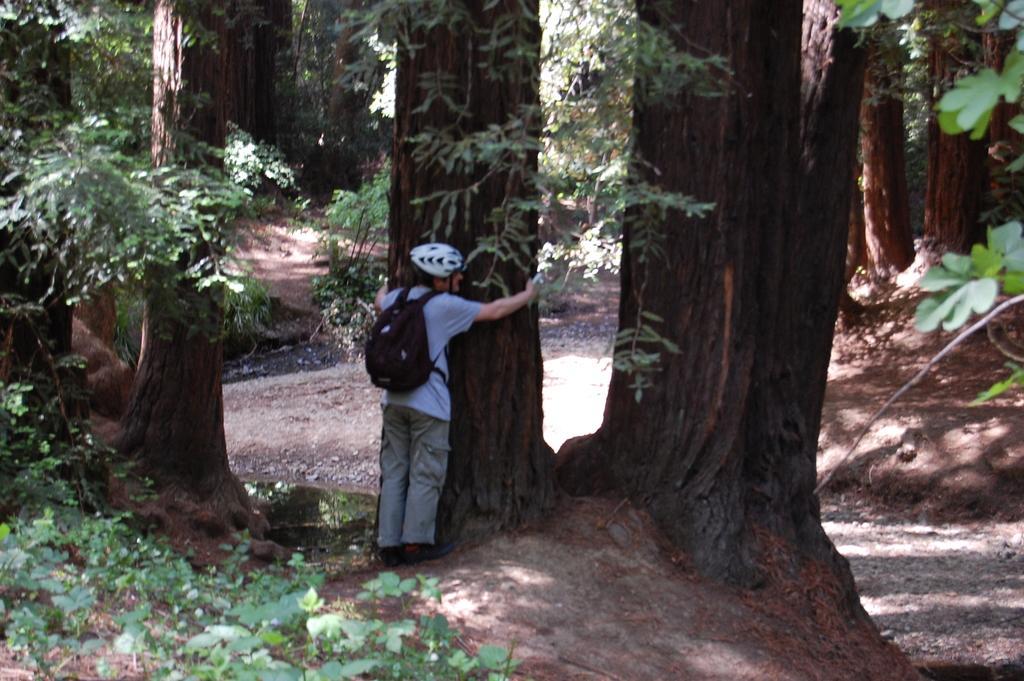Can you describe this image briefly? In this image, we can see a person standing and holding a tree trunk, that person is wearing a bag and wearing a helmet, we can see some plants and trees. We can see the way. 